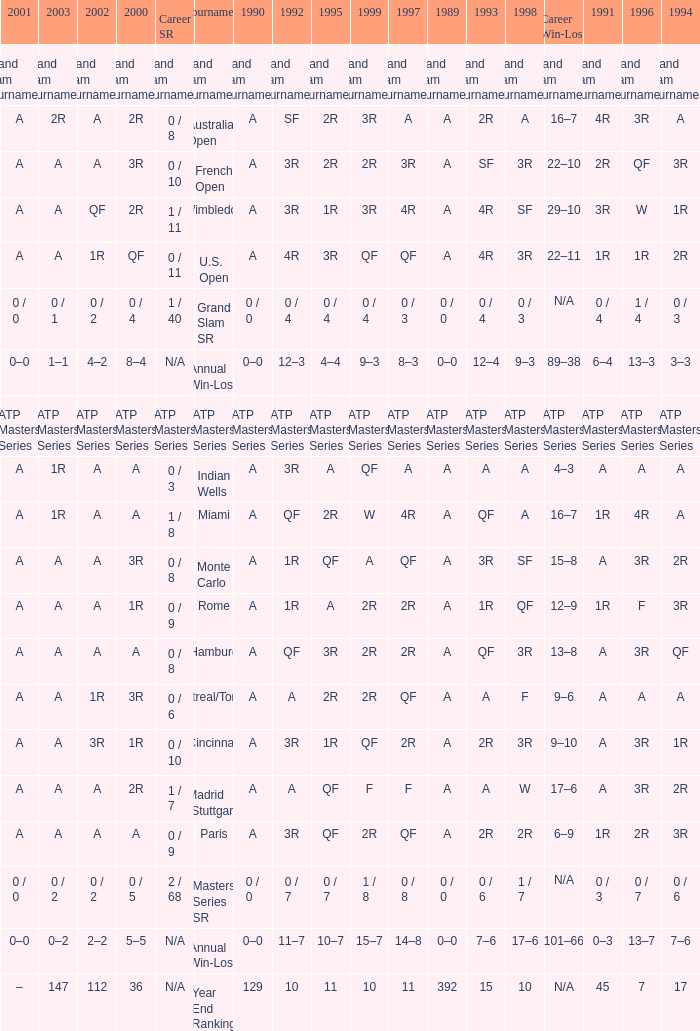In the 2000 indian wells tournament, what was a's value in 1995? A. 